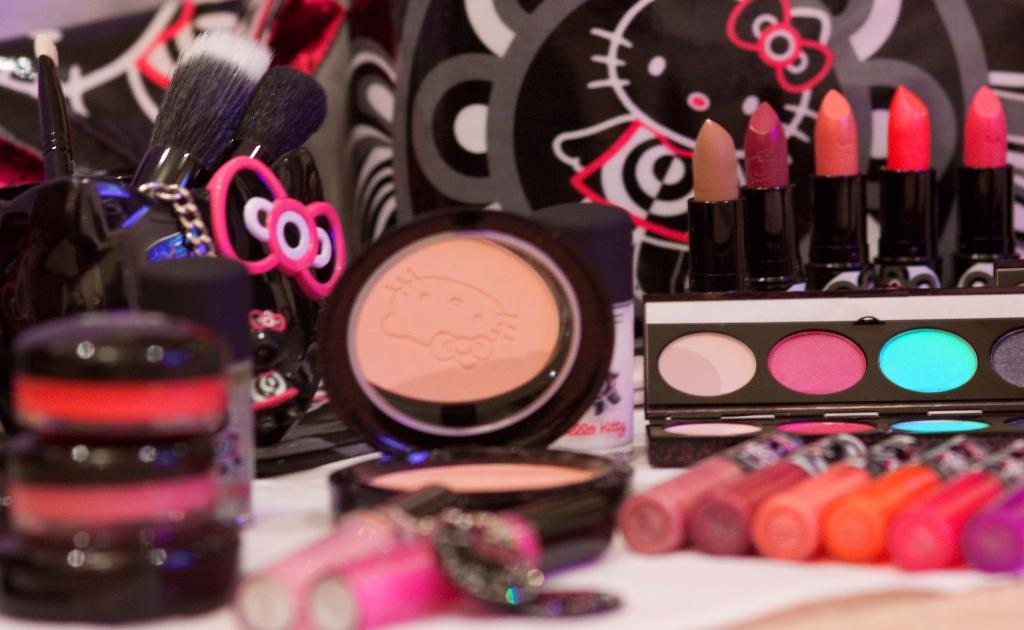What type of items can be seen on the table in the image? There are cosmetics, lipsticks, brushes, and foundation powder on the table. Can you describe the cosmetics in more detail? The cosmetics include lipsticks and foundation powder. What tools are present on the table for applying the cosmetics? There are brushes on the table for applying the cosmetics. Where is the camera located in the image? There is no camera present in the image. Can you describe the honey that is being used in the image? There is no honey present in the image. 